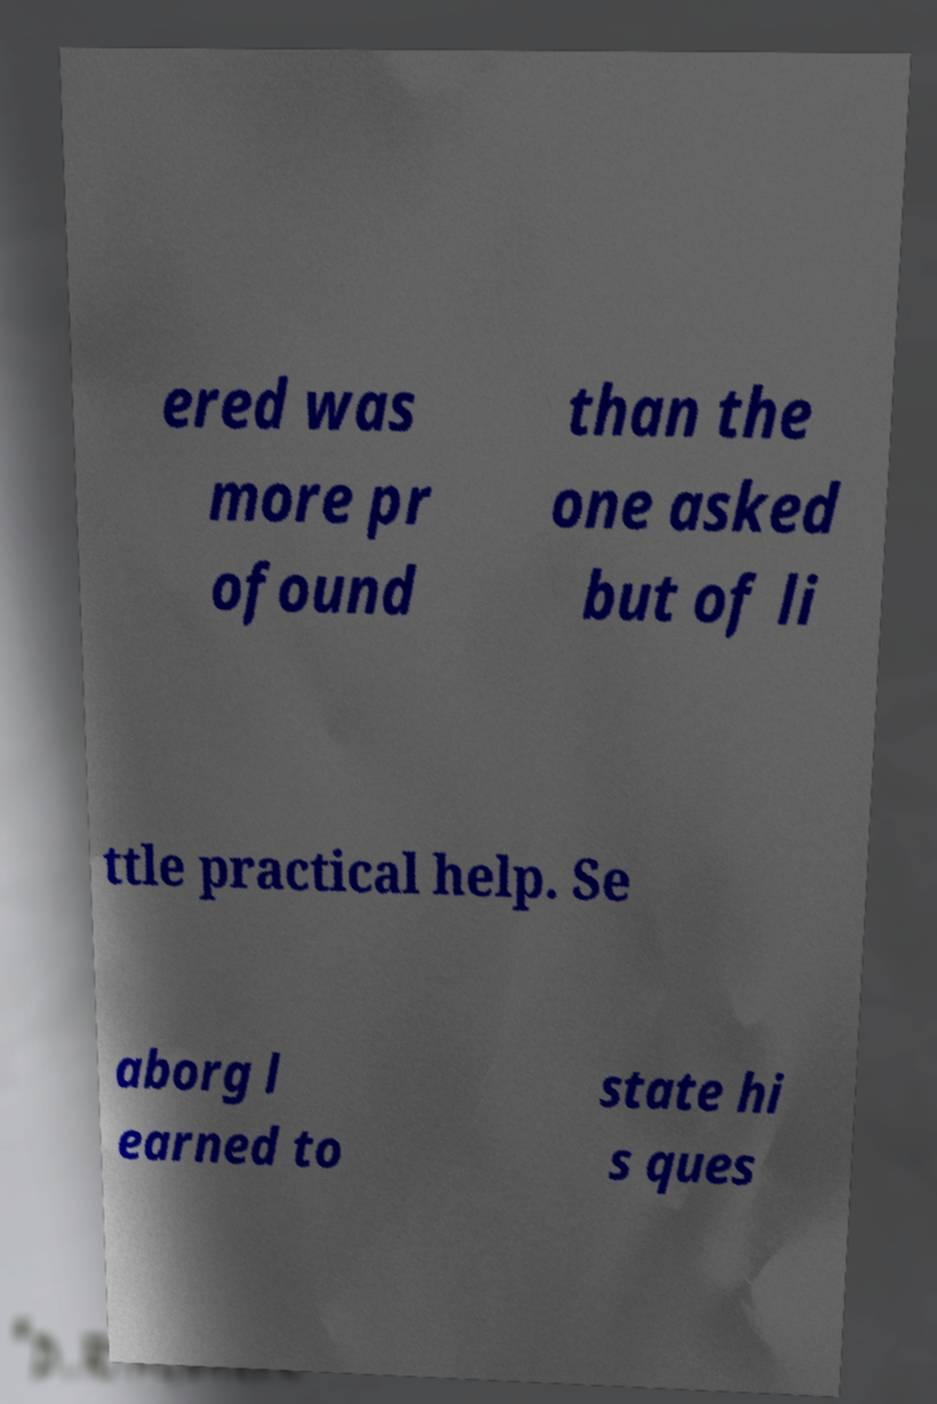Could you extract and type out the text from this image? ered was more pr ofound than the one asked but of li ttle practical help. Se aborg l earned to state hi s ques 